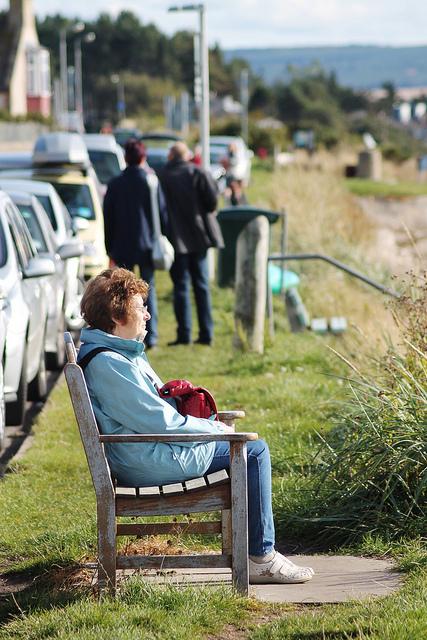Will the woman answer negatively if asked if its warmer than 35 degrees?
Quick response, please. No. What kind of glasses is the woman wearing?
Write a very short answer. Reading. What is the frame of the bench made of?
Be succinct. Wood. Does the woman have curly hair?
Concise answer only. No. Is the woman sitting?
Write a very short answer. Yes. What is the woman sitting on?
Give a very brief answer. Chair. 